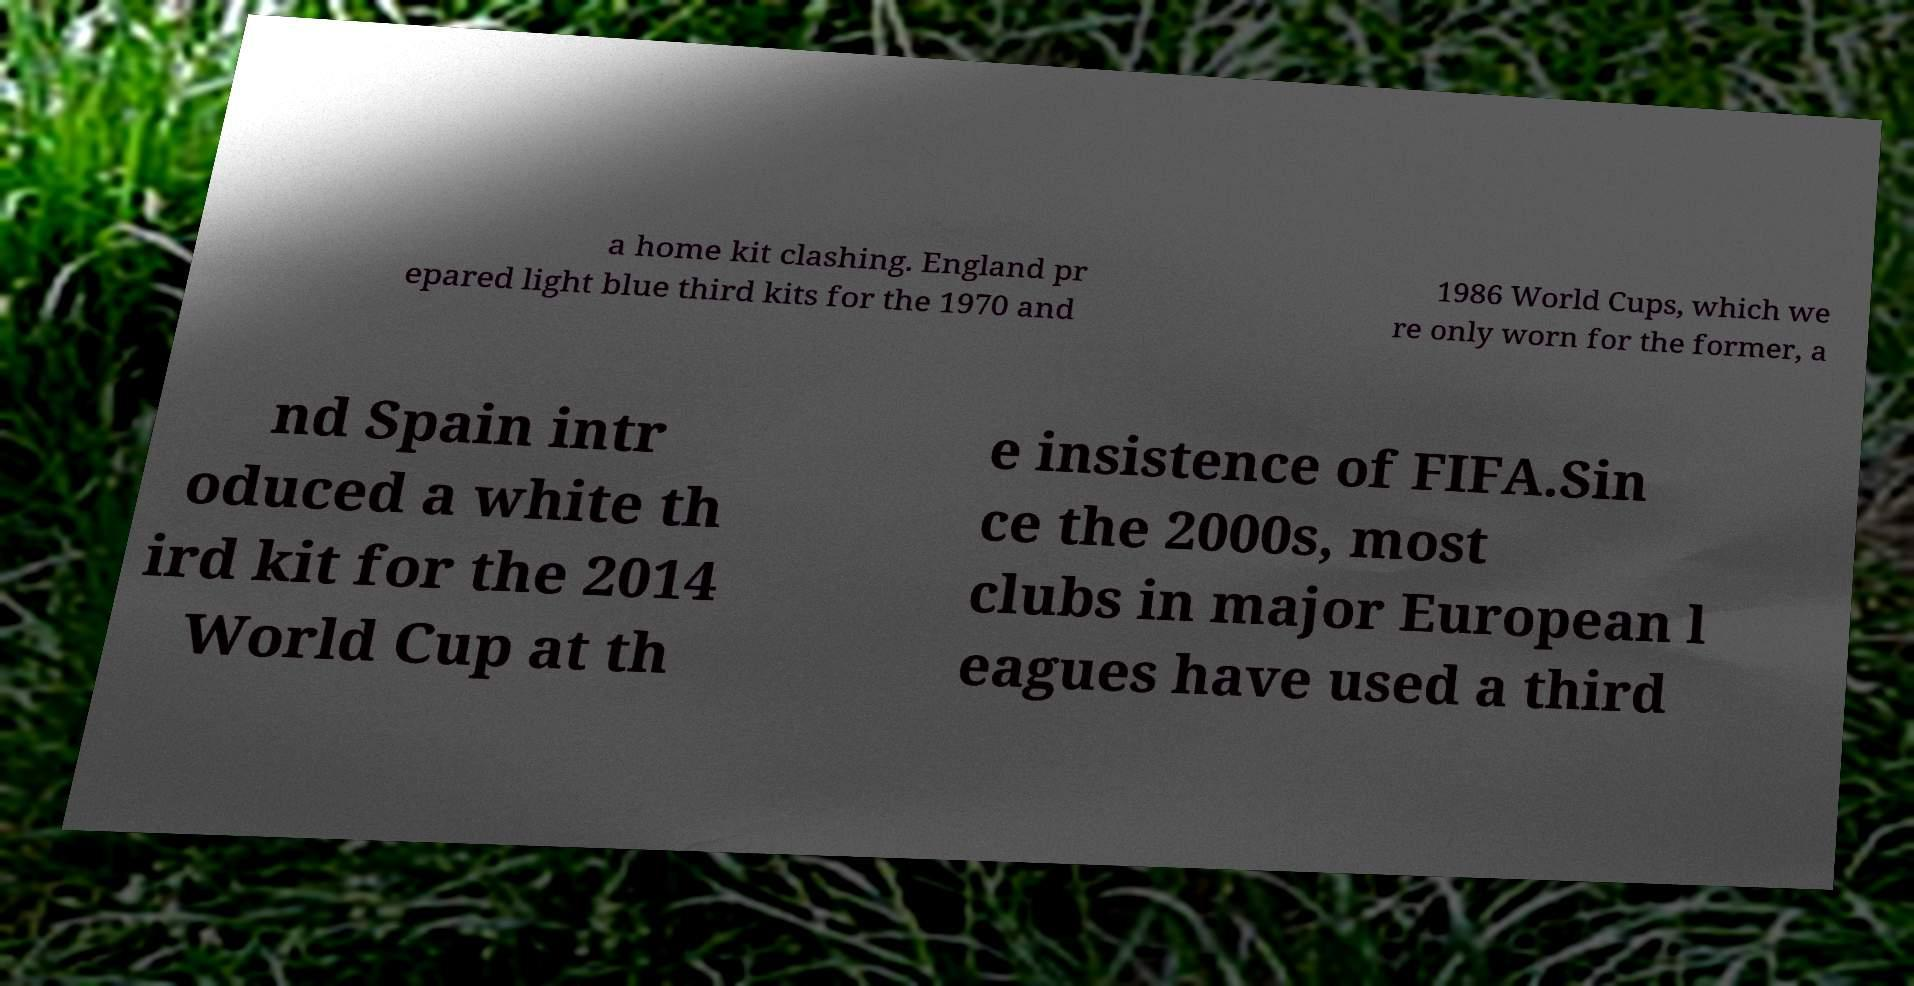For documentation purposes, I need the text within this image transcribed. Could you provide that? a home kit clashing. England pr epared light blue third kits for the 1970 and 1986 World Cups, which we re only worn for the former, a nd Spain intr oduced a white th ird kit for the 2014 World Cup at th e insistence of FIFA.Sin ce the 2000s, most clubs in major European l eagues have used a third 